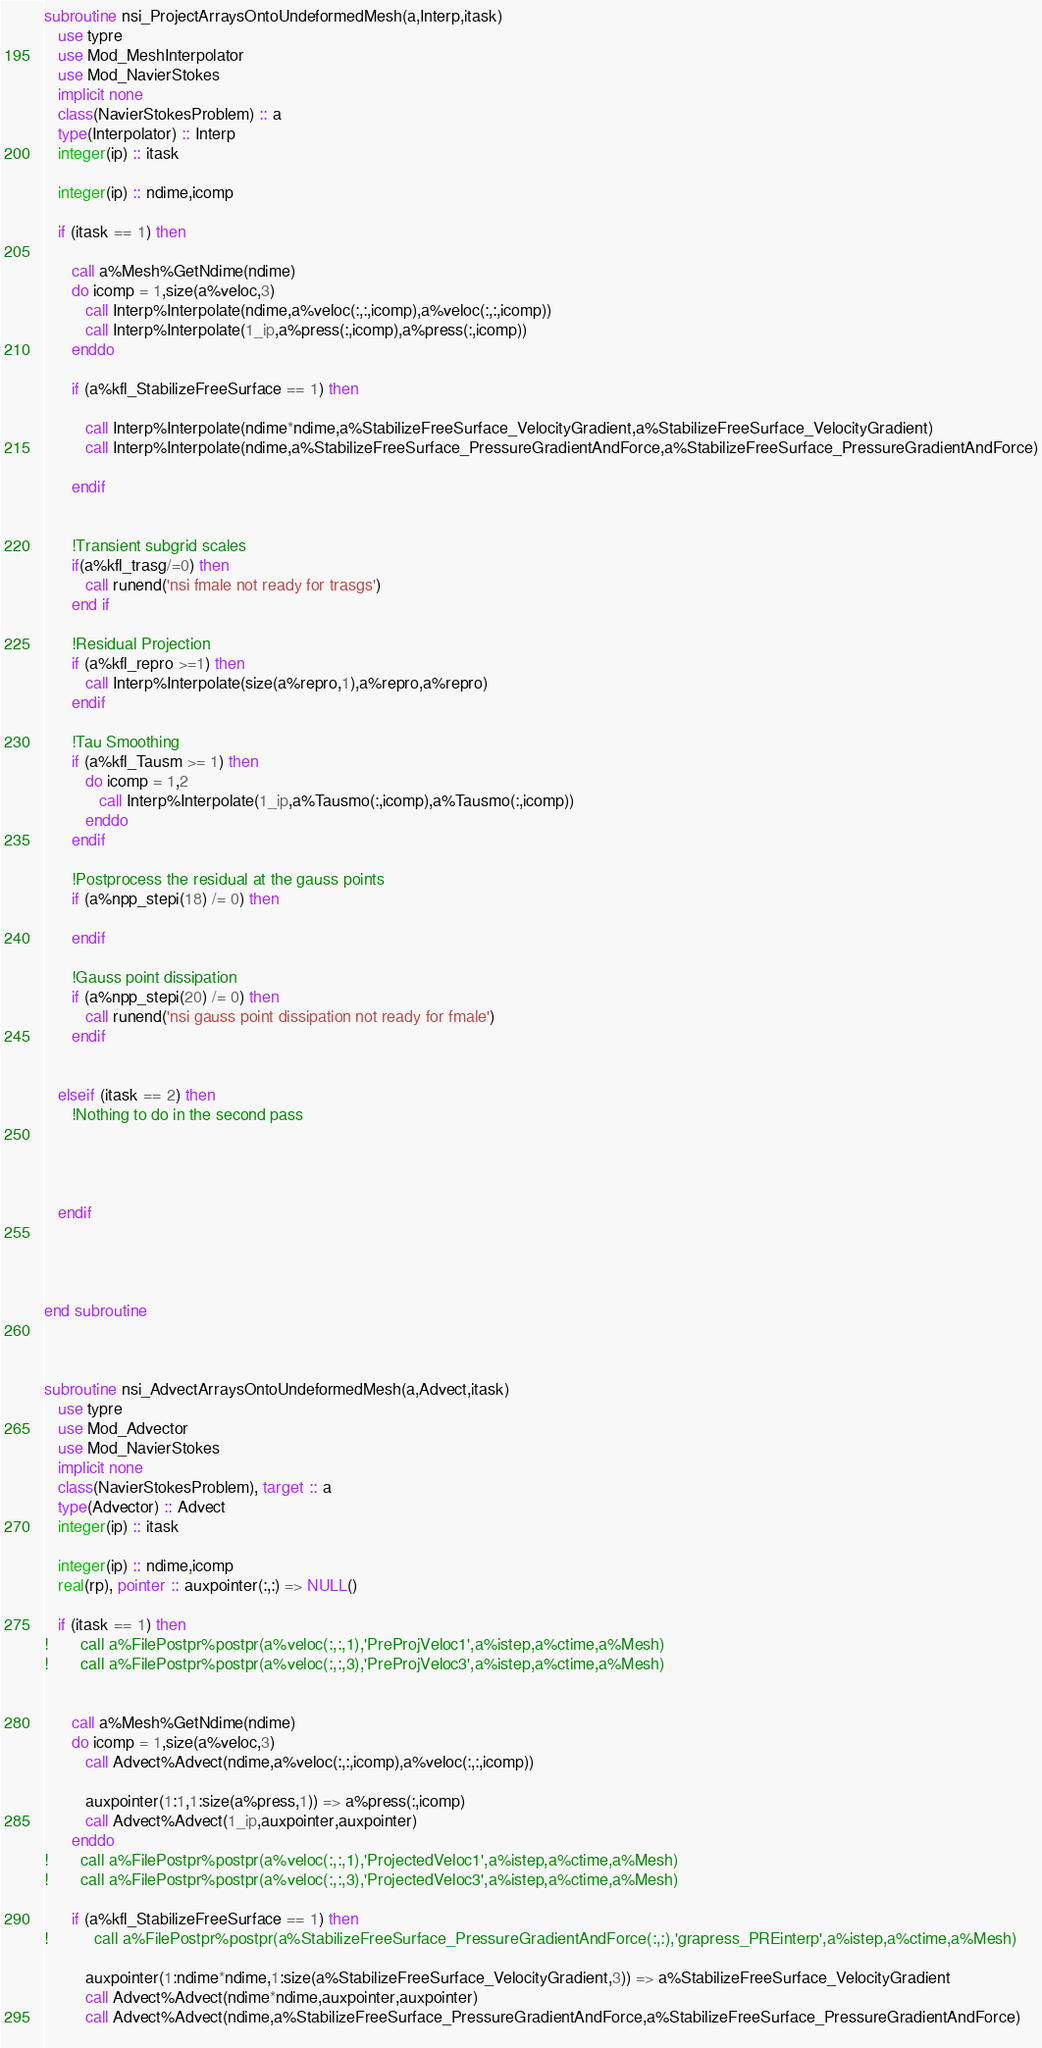Convert code to text. <code><loc_0><loc_0><loc_500><loc_500><_FORTRAN_>subroutine nsi_ProjectArraysOntoUndeformedMesh(a,Interp,itask)
   use typre
   use Mod_MeshInterpolator
   use Mod_NavierStokes
   implicit none
   class(NavierStokesProblem) :: a
   type(Interpolator) :: Interp
   integer(ip) :: itask
   
   integer(ip) :: ndime,icomp
   
   if (itask == 1) then
   
      call a%Mesh%GetNdime(ndime)
      do icomp = 1,size(a%veloc,3)
         call Interp%Interpolate(ndime,a%veloc(:,:,icomp),a%veloc(:,:,icomp))
         call Interp%Interpolate(1_ip,a%press(:,icomp),a%press(:,icomp))
      enddo

      if (a%kfl_StabilizeFreeSurface == 1) then
      
         call Interp%Interpolate(ndime*ndime,a%StabilizeFreeSurface_VelocityGradient,a%StabilizeFreeSurface_VelocityGradient)
         call Interp%Interpolate(ndime,a%StabilizeFreeSurface_PressureGradientAndForce,a%StabilizeFreeSurface_PressureGradientAndForce)
         
      endif
   
   
      !Transient subgrid scales
      if(a%kfl_trasg/=0) then
         call runend('nsi fmale not ready for trasgs')
      end if
      
      !Residual Projection
      if (a%kfl_repro >=1) then
         call Interp%Interpolate(size(a%repro,1),a%repro,a%repro)
      endif
      
      !Tau Smoothing
      if (a%kfl_Tausm >= 1) then
         do icomp = 1,2
            call Interp%Interpolate(1_ip,a%Tausmo(:,icomp),a%Tausmo(:,icomp))
         enddo
      endif
      
      !Postprocess the residual at the gauss points
      if (a%npp_stepi(18) /= 0) then
               
      endif
      
      !Gauss point dissipation
      if (a%npp_stepi(20) /= 0) then
         call runend('nsi gauss point dissipation not ready for fmale')
      endif
      
      
   elseif (itask == 2) then   
      !Nothing to do in the second pass
      
      
      
      
   endif
   
   


end subroutine



subroutine nsi_AdvectArraysOntoUndeformedMesh(a,Advect,itask)
   use typre
   use Mod_Advector
   use Mod_NavierStokes
   implicit none
   class(NavierStokesProblem), target :: a
   type(Advector) :: Advect
   integer(ip) :: itask
   
   integer(ip) :: ndime,icomp
   real(rp), pointer :: auxpointer(:,:) => NULL()
   
   if (itask == 1) then
!       call a%FilePostpr%postpr(a%veloc(:,:,1),'PreProjVeloc1',a%istep,a%ctime,a%Mesh)
!       call a%FilePostpr%postpr(a%veloc(:,:,3),'PreProjVeloc3',a%istep,a%ctime,a%Mesh)

   
      call a%Mesh%GetNdime(ndime)
      do icomp = 1,size(a%veloc,3)
         call Advect%Advect(ndime,a%veloc(:,:,icomp),a%veloc(:,:,icomp))
         
         auxpointer(1:1,1:size(a%press,1)) => a%press(:,icomp)
         call Advect%Advect(1_ip,auxpointer,auxpointer)
      enddo
!       call a%FilePostpr%postpr(a%veloc(:,:,1),'ProjectedVeloc1',a%istep,a%ctime,a%Mesh)
!       call a%FilePostpr%postpr(a%veloc(:,:,3),'ProjectedVeloc3',a%istep,a%ctime,a%Mesh)

      if (a%kfl_StabilizeFreeSurface == 1) then
!          call a%FilePostpr%postpr(a%StabilizeFreeSurface_PressureGradientAndForce(:,:),'grapress_PREinterp',a%istep,a%ctime,a%Mesh)
         
         auxpointer(1:ndime*ndime,1:size(a%StabilizeFreeSurface_VelocityGradient,3)) => a%StabilizeFreeSurface_VelocityGradient
         call Advect%Advect(ndime*ndime,auxpointer,auxpointer)
         call Advect%Advect(ndime,a%StabilizeFreeSurface_PressureGradientAndForce,a%StabilizeFreeSurface_PressureGradientAndForce)
         </code> 